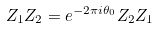Convert formula to latex. <formula><loc_0><loc_0><loc_500><loc_500>Z _ { 1 } Z _ { 2 } = e ^ { - 2 \pi i \theta _ { 0 } } Z _ { 2 } Z _ { 1 }</formula> 